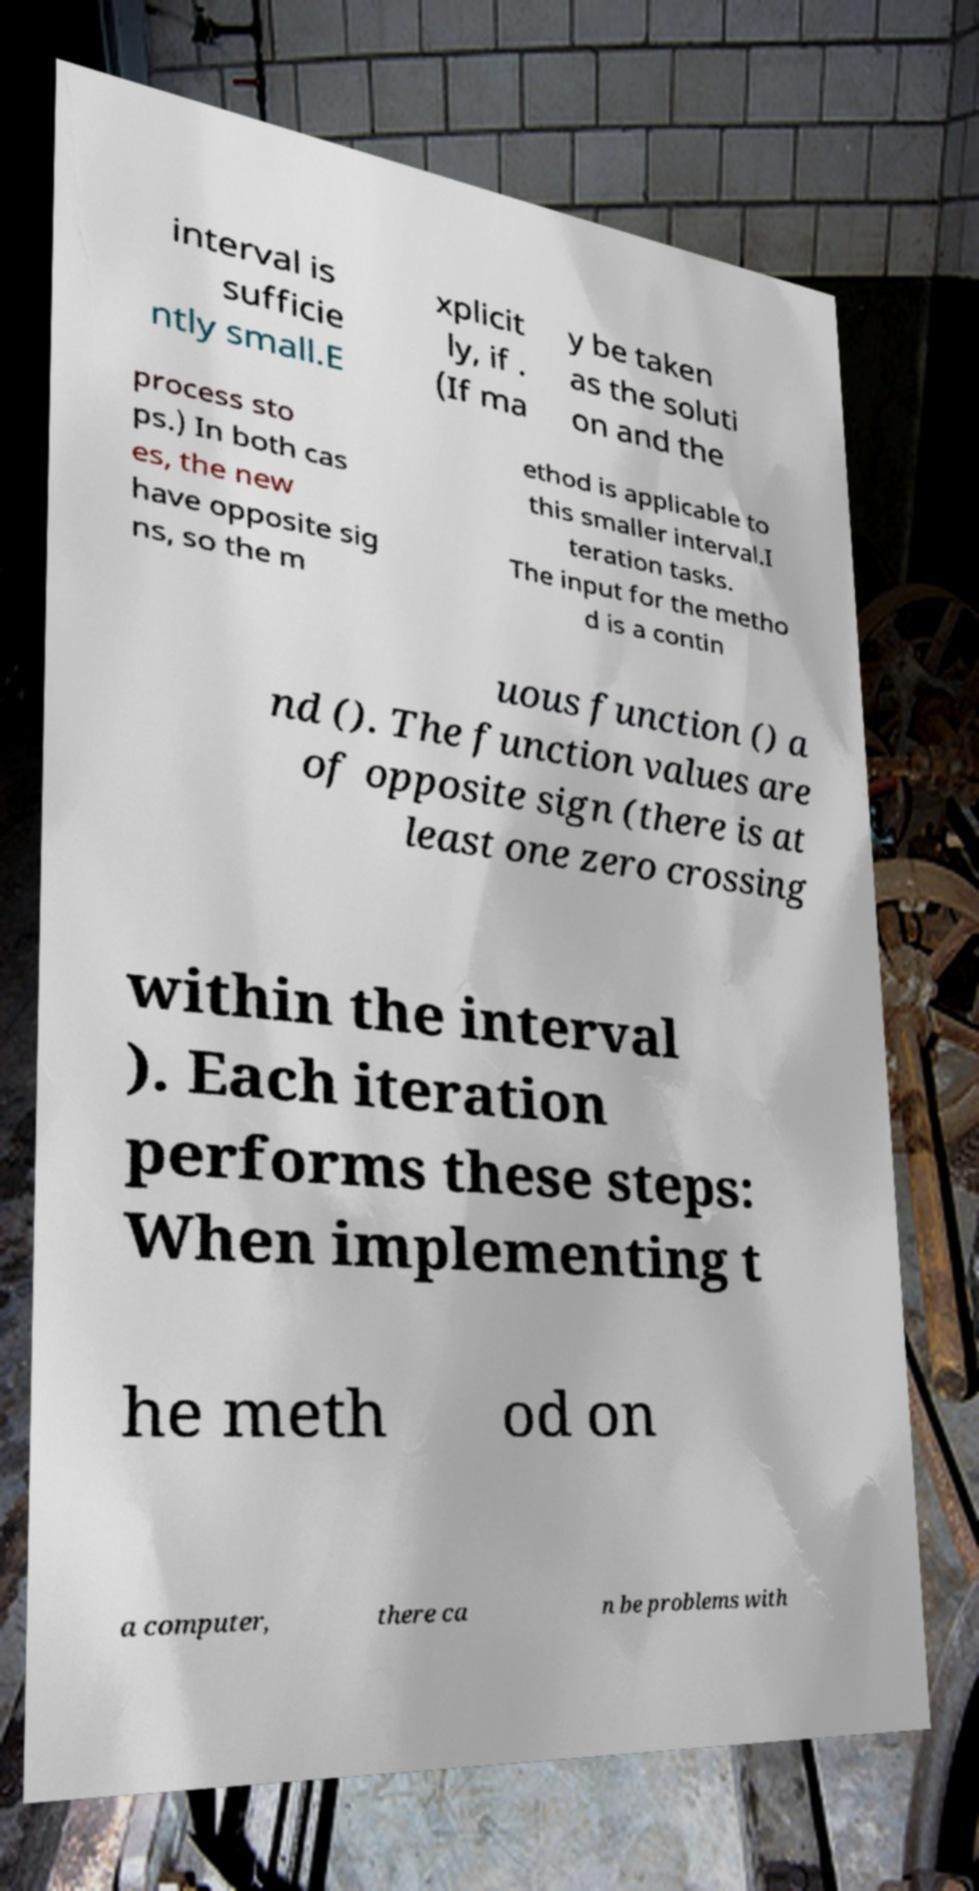Can you read and provide the text displayed in the image?This photo seems to have some interesting text. Can you extract and type it out for me? interval is sufficie ntly small.E xplicit ly, if . (If ma y be taken as the soluti on and the process sto ps.) In both cas es, the new have opposite sig ns, so the m ethod is applicable to this smaller interval.I teration tasks. The input for the metho d is a contin uous function () a nd (). The function values are of opposite sign (there is at least one zero crossing within the interval ). Each iteration performs these steps: When implementing t he meth od on a computer, there ca n be problems with 